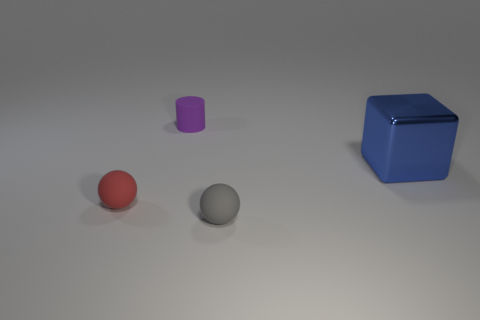There is a tiny sphere behind the tiny ball to the right of the small purple rubber object; what number of small objects are behind it?
Your response must be concise. 1. Is there any other thing that is the same size as the purple matte object?
Make the answer very short. Yes. What is the shape of the tiny rubber thing on the right side of the tiny rubber thing behind the sphere left of the tiny purple rubber object?
Make the answer very short. Sphere. There is a tiny thing in front of the small thing to the left of the tiny purple cylinder; what is its shape?
Your answer should be compact. Sphere. There is a big blue metal block; how many tiny red spheres are in front of it?
Your answer should be very brief. 1. Are there any small red blocks made of the same material as the gray ball?
Give a very brief answer. No. There is a red thing that is the same size as the purple matte object; what is its material?
Ensure brevity in your answer.  Rubber. There is a matte thing that is both to the right of the tiny red rubber ball and in front of the metal block; what size is it?
Ensure brevity in your answer.  Small. There is a tiny matte object that is both right of the red thing and in front of the tiny purple rubber cylinder; what is its color?
Make the answer very short. Gray. Are there fewer matte spheres behind the gray object than large blue blocks that are behind the blue cube?
Ensure brevity in your answer.  No. 